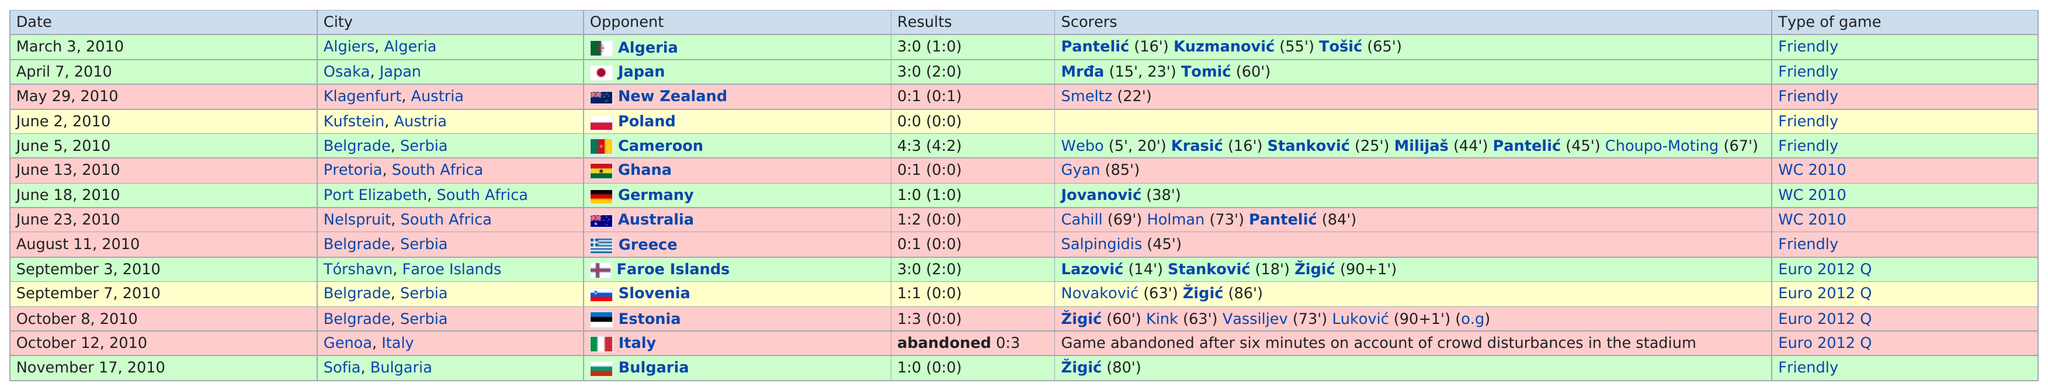Point out several critical features in this image. The first Asian country that appears on this table is Japan. The number of times Belgrade is listed as the city is 4. Serbia played a total of 7 games in 2010, excluding friendly matches. The word "friendly" is a type of game 7 times. On June 2, 2010, the results were below one. 